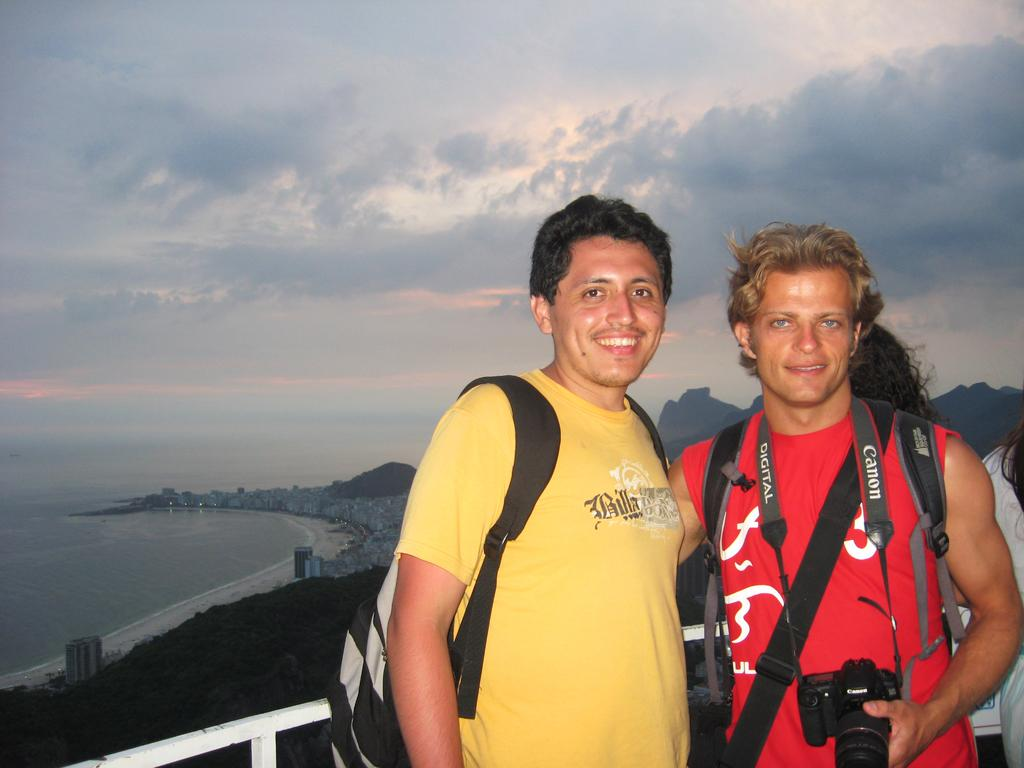What can be seen in the sky in the image? There is no specific detail about the sky in the image, but we know that there is a sky present. What is the main feature of the water in the image? There is no specific detail about the water in the image, but we know that there is water present. What type of vegetation is in the image? There are trees in the image. How many people are in the image? There are two people in the image. Can you describe the man in the image? One of the people is a man standing on the right side, and he is holding a camera. What type of shoe is the servant wearing in the image? There is no servant or shoe present in the image. What self-reflection does the man have about his photography skills in the image? There is no indication of the man's self-reflection about his photography skills in the image. 